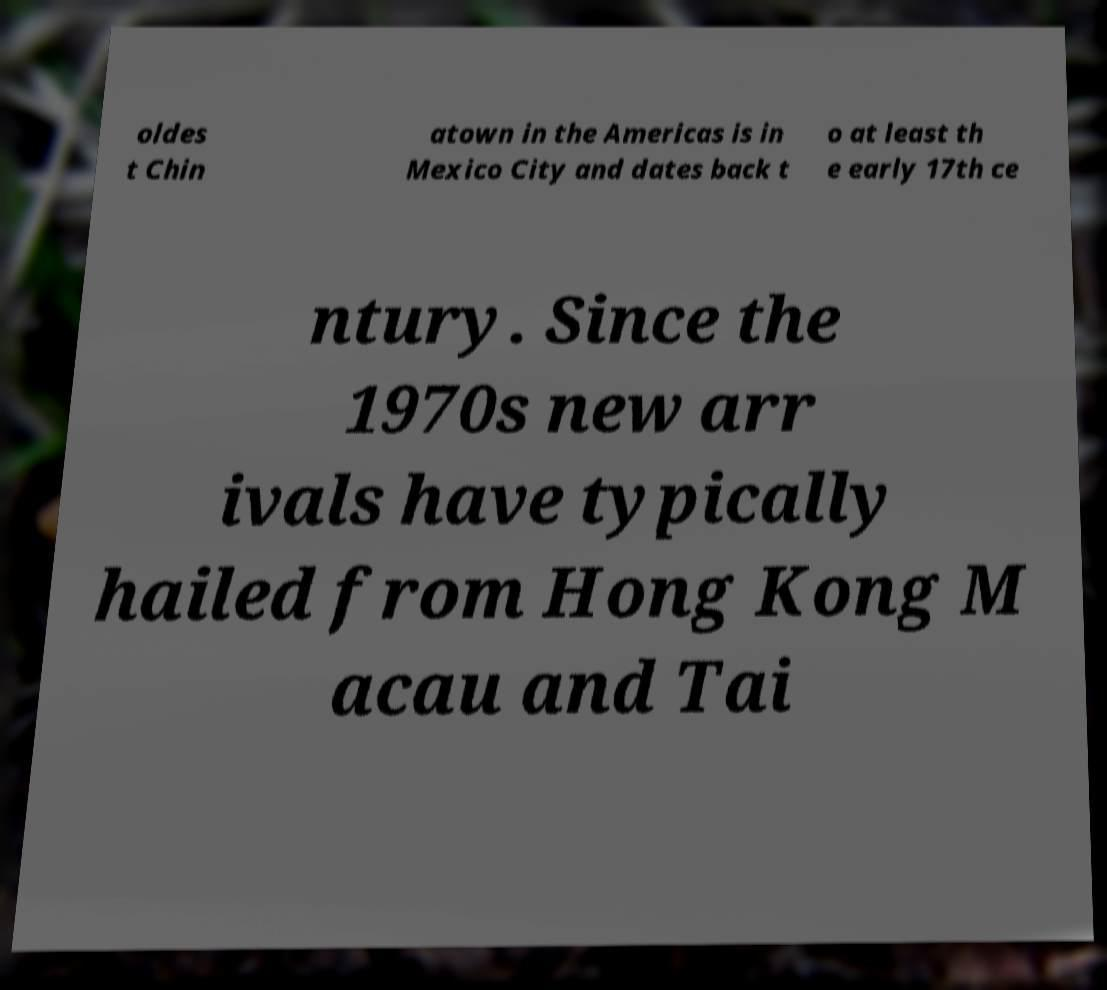Can you read and provide the text displayed in the image?This photo seems to have some interesting text. Can you extract and type it out for me? oldes t Chin atown in the Americas is in Mexico City and dates back t o at least th e early 17th ce ntury. Since the 1970s new arr ivals have typically hailed from Hong Kong M acau and Tai 